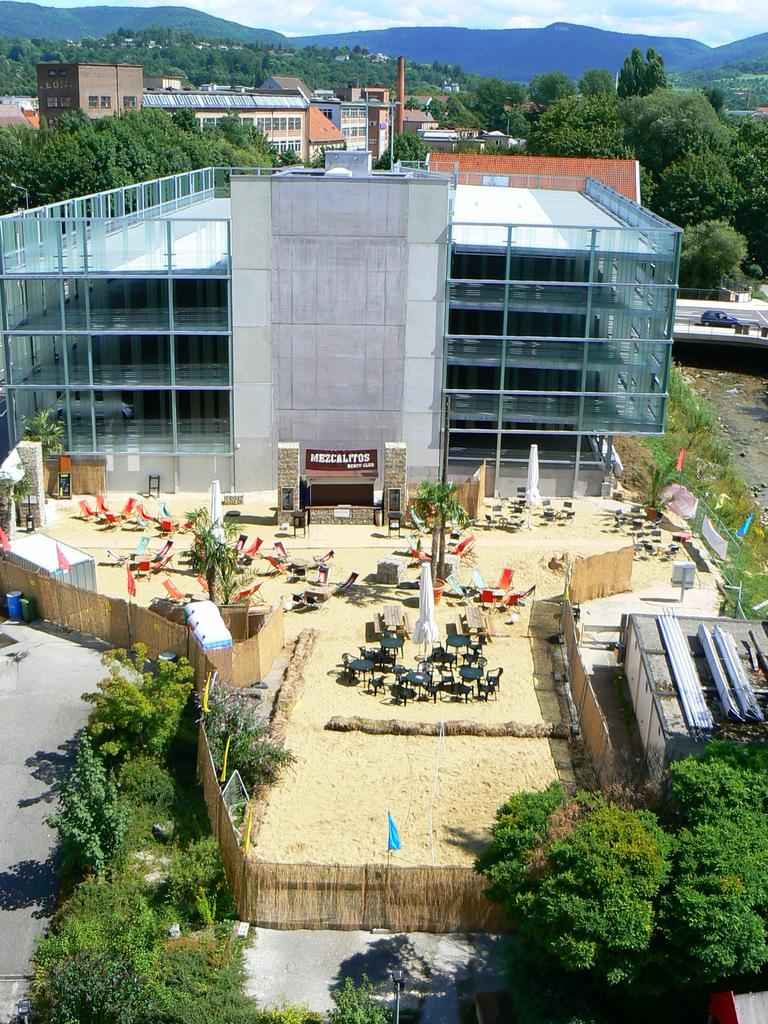What type of structures can be seen in the image? There are buildings in the image. What other natural elements are present in the image? There are trees in the image. What objects are placed in front of the building? There are chairs and a fence in front of the building. Are there any decorative elements in front of the building? Yes, there are flags in front of the building. What can be seen in the distance in the image? There is a mountain visible in the distance. What type of lizards can be seen crawling on the canvas in the image? There are no lizards or canvas present in the image. What type of poison is being used to treat the trees in the image? There is no mention of poison or tree treatment in the image. 